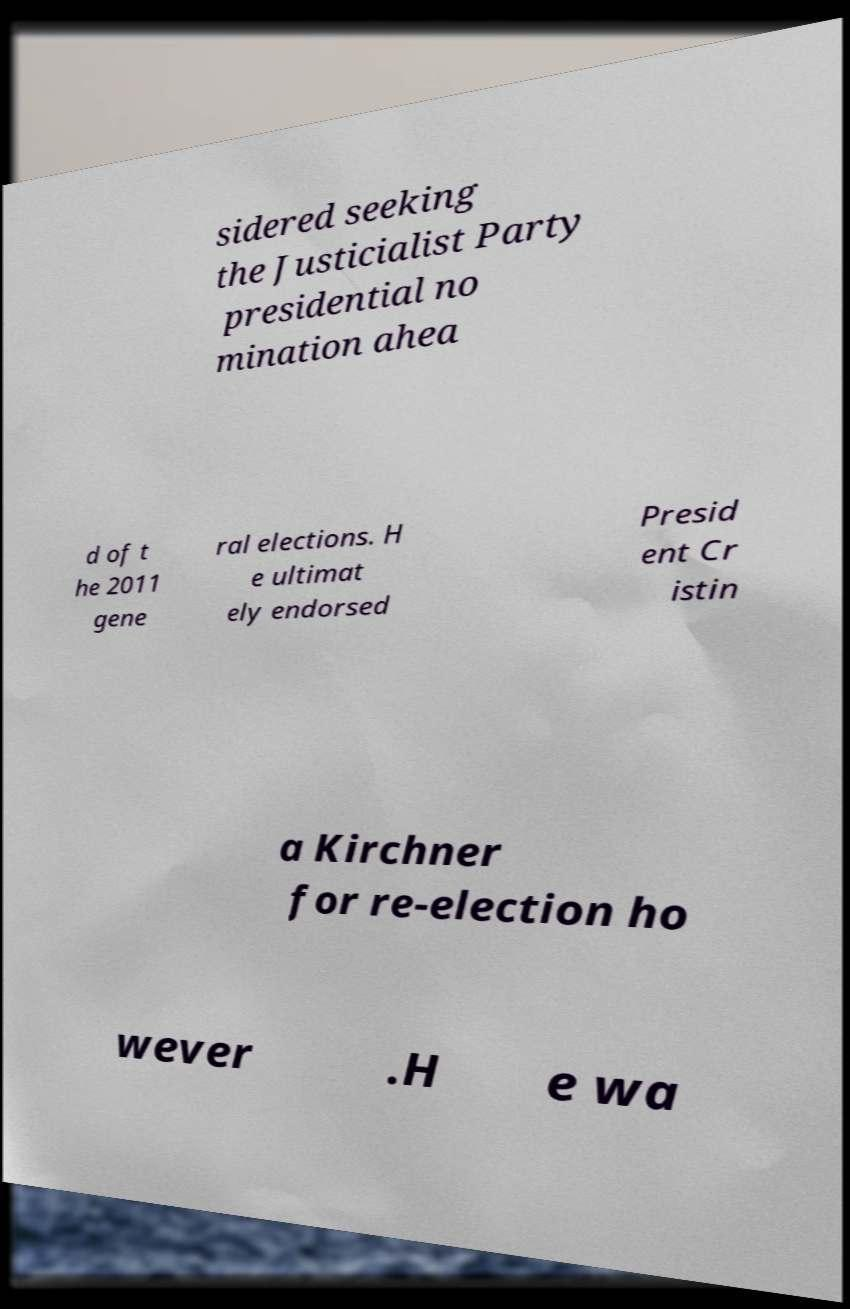Please identify and transcribe the text found in this image. sidered seeking the Justicialist Party presidential no mination ahea d of t he 2011 gene ral elections. H e ultimat ely endorsed Presid ent Cr istin a Kirchner for re-election ho wever .H e wa 